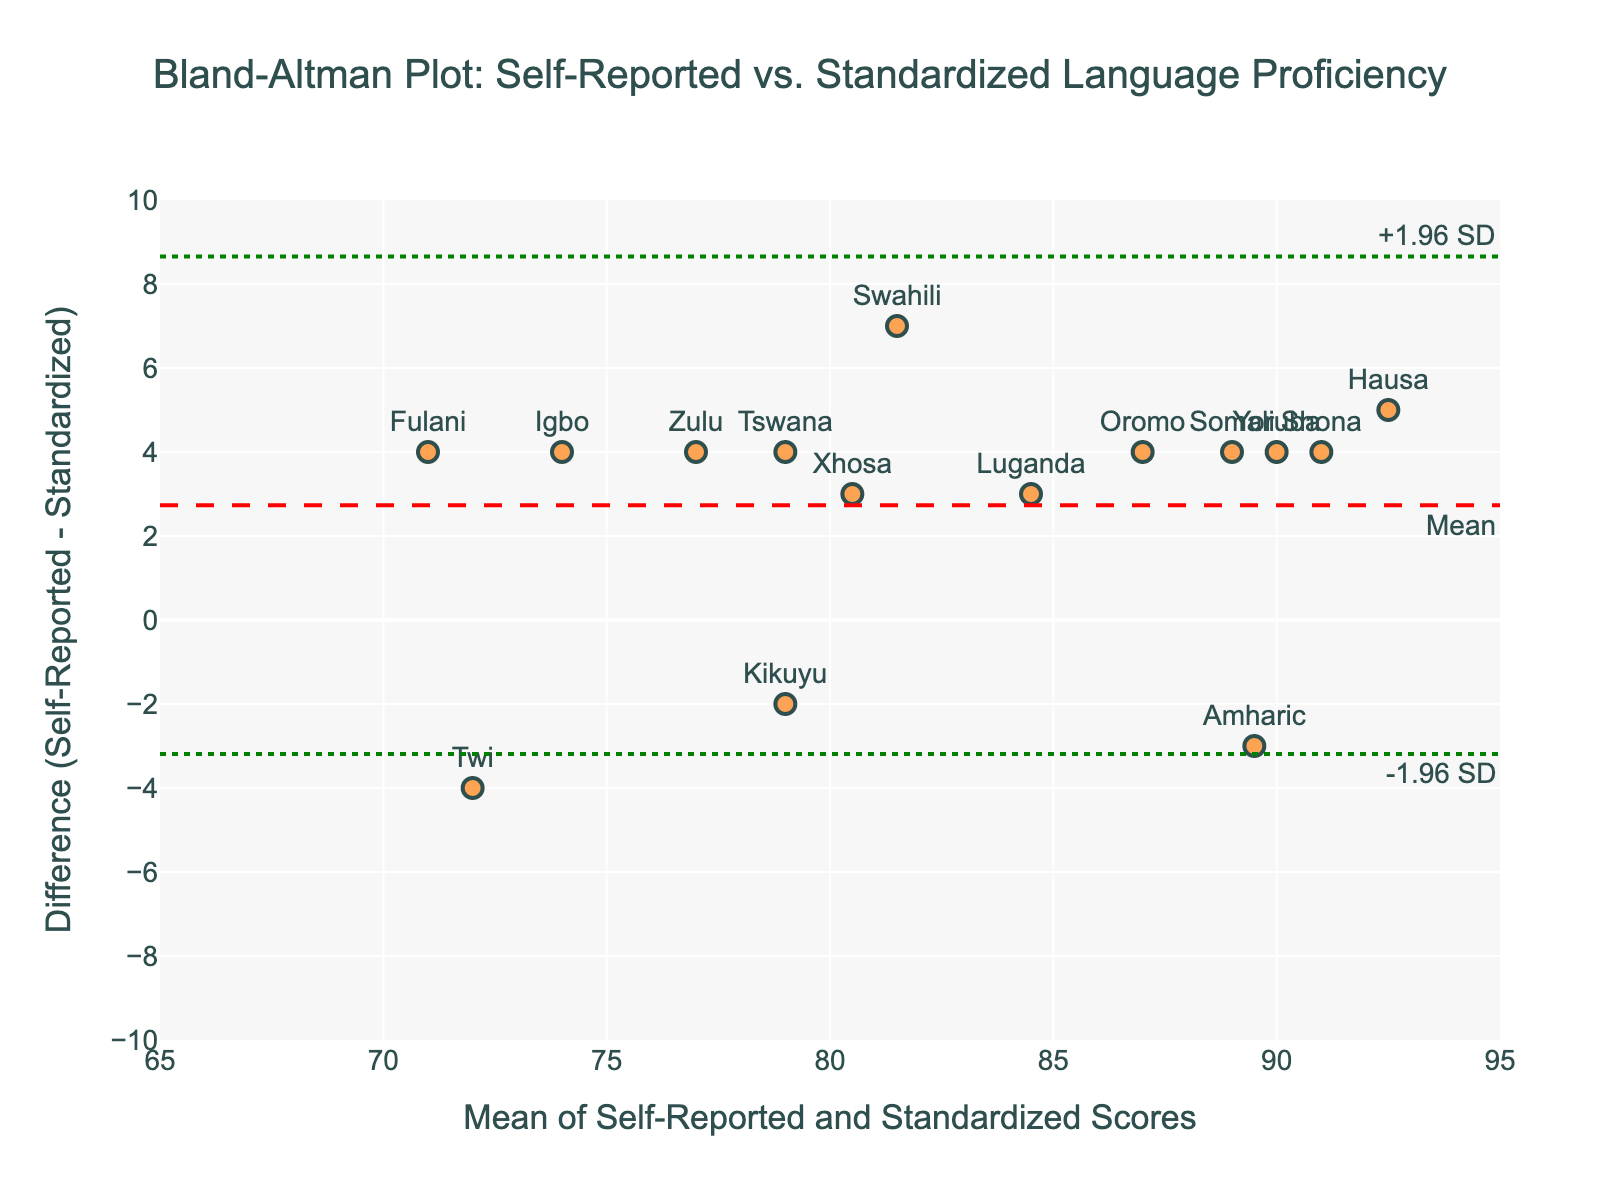What is the title of the plot? The title of the plot is located at the top center of the figure.
Answer: Bland-Altman Plot: Self-Reported vs. Standardized Language Proficiency What does the y-axis represent? The y-axis represents the difference between self-reported proficiency and standardized test scores, as labeled.
Answer: Difference (Self-Reported - Standardized) What is the range of the x-axis? The x-axis has ticks labeled from 65 to 95, so the range is from 65 to 95.
Answer: 65 to 95 How many data points are there on the plot? Each language represents one data point, and there are 15 languages in the dataset as indicated by the markers and text labels on the plot.
Answer: 15 Which language has the highest difference between self-reported proficiency and standardized test scores? The highest positive difference can be identified by locating the marker with the highest y-value.
Answer: Hausa What is the mean difference between self-reported proficiency and standardized test scores? The mean difference is represented by the red dashed line on the plot, annotated with "Mean".
Answer: Mean What are the upper and lower limits of agreement? The green dotted lines on the plot, annotated as "+1.96 SD" and "-1.96 SD", represent the upper and lower limits of agreement.
Answer: +1.96 SD, -1.96 SD Is there any language for which the standardized test score is higher than the self-reported proficiency? Look for markers below the y=0 line, which indicates a negative difference where the standardized score is higher.
Answer: Amharic, Kikuyu, Twi Which data point is closest to the mean difference line? Identify the marker closest to the red dashed line, labeled "Mean".
Answer: Kikuyu For which languages is the self-reported proficiency equal to the standardized test scores? There are no data points exactly on the y=0 line, which means no languages have equal self-reported and standardized scores.
Answer: None 